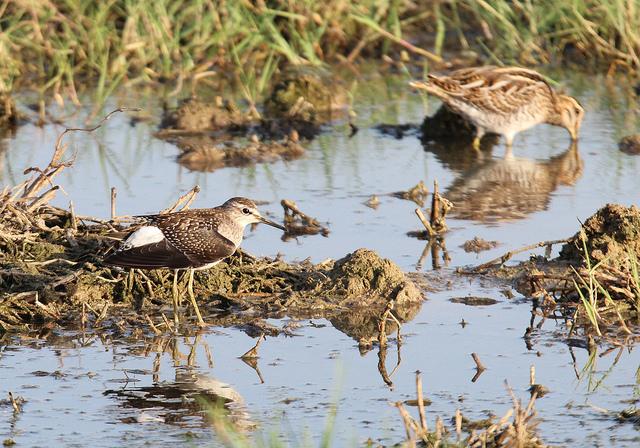What two colors do these birds seem to be?
Answer briefly. Brown and white. How many birds are there?
Concise answer only. 2. Are the birds flying?
Answer briefly. No. Are there flowers here?
Answer briefly. No. What are the birds standing on?
Concise answer only. Water. 